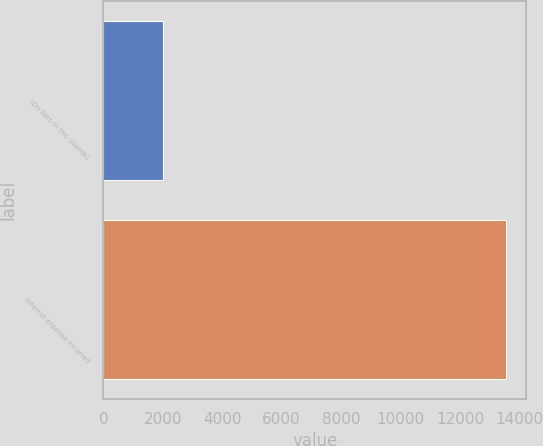Convert chart. <chart><loc_0><loc_0><loc_500><loc_500><bar_chart><fcel>(Do llars in tho usands)<fcel>Interest expense incurred<nl><fcel>2013<fcel>13551<nl></chart> 